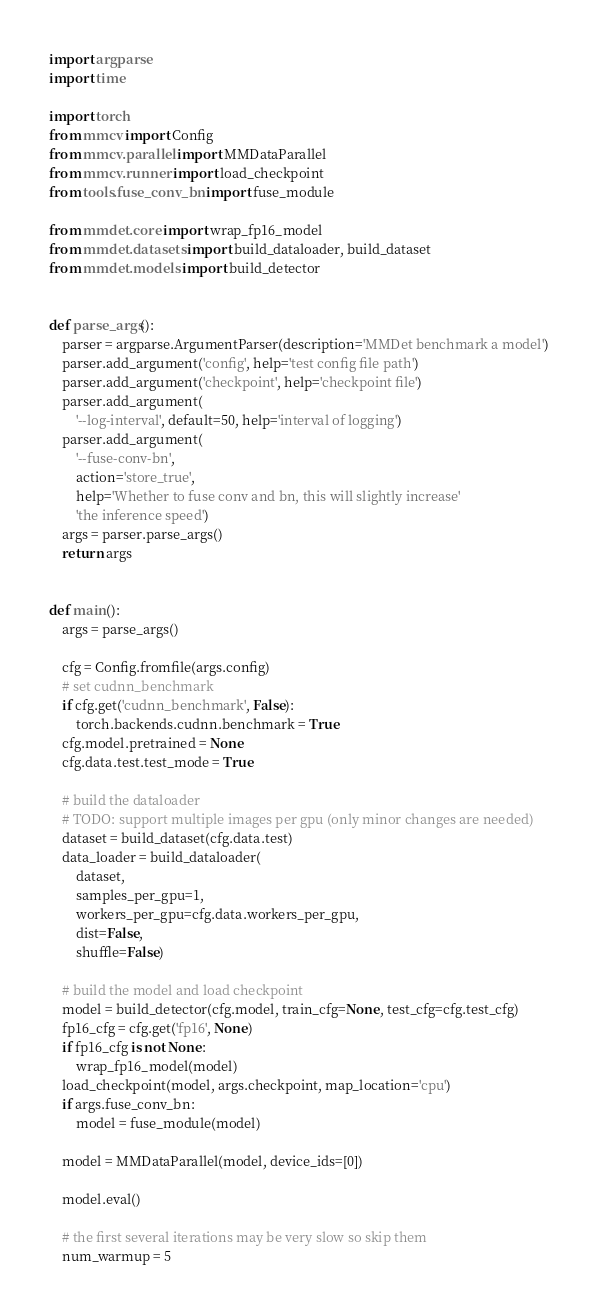<code> <loc_0><loc_0><loc_500><loc_500><_Python_>import argparse
import time

import torch
from mmcv import Config
from mmcv.parallel import MMDataParallel
from mmcv.runner import load_checkpoint
from tools.fuse_conv_bn import fuse_module

from mmdet.core import wrap_fp16_model
from mmdet.datasets import build_dataloader, build_dataset
from mmdet.models import build_detector


def parse_args():
    parser = argparse.ArgumentParser(description='MMDet benchmark a model')
    parser.add_argument('config', help='test config file path')
    parser.add_argument('checkpoint', help='checkpoint file')
    parser.add_argument(
        '--log-interval', default=50, help='interval of logging')
    parser.add_argument(
        '--fuse-conv-bn',
        action='store_true',
        help='Whether to fuse conv and bn, this will slightly increase'
        'the inference speed')
    args = parser.parse_args()
    return args


def main():
    args = parse_args()

    cfg = Config.fromfile(args.config)
    # set cudnn_benchmark
    if cfg.get('cudnn_benchmark', False):
        torch.backends.cudnn.benchmark = True
    cfg.model.pretrained = None
    cfg.data.test.test_mode = True

    # build the dataloader
    # TODO: support multiple images per gpu (only minor changes are needed)
    dataset = build_dataset(cfg.data.test)
    data_loader = build_dataloader(
        dataset,
        samples_per_gpu=1,
        workers_per_gpu=cfg.data.workers_per_gpu,
        dist=False,
        shuffle=False)

    # build the model and load checkpoint
    model = build_detector(cfg.model, train_cfg=None, test_cfg=cfg.test_cfg)
    fp16_cfg = cfg.get('fp16', None)
    if fp16_cfg is not None:
        wrap_fp16_model(model)
    load_checkpoint(model, args.checkpoint, map_location='cpu')
    if args.fuse_conv_bn:
        model = fuse_module(model)

    model = MMDataParallel(model, device_ids=[0])

    model.eval()

    # the first several iterations may be very slow so skip them
    num_warmup = 5</code> 